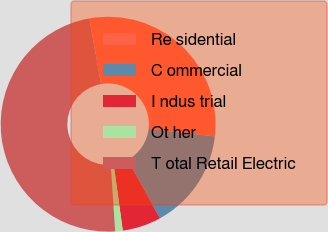Convert chart. <chart><loc_0><loc_0><loc_500><loc_500><pie_chart><fcel>Re sidential<fcel>C ommercial<fcel>I ndus trial<fcel>Ot her<fcel>T otal Retail Electric<nl><fcel>29.61%<fcel>15.17%<fcel>5.84%<fcel>1.13%<fcel>48.25%<nl></chart> 